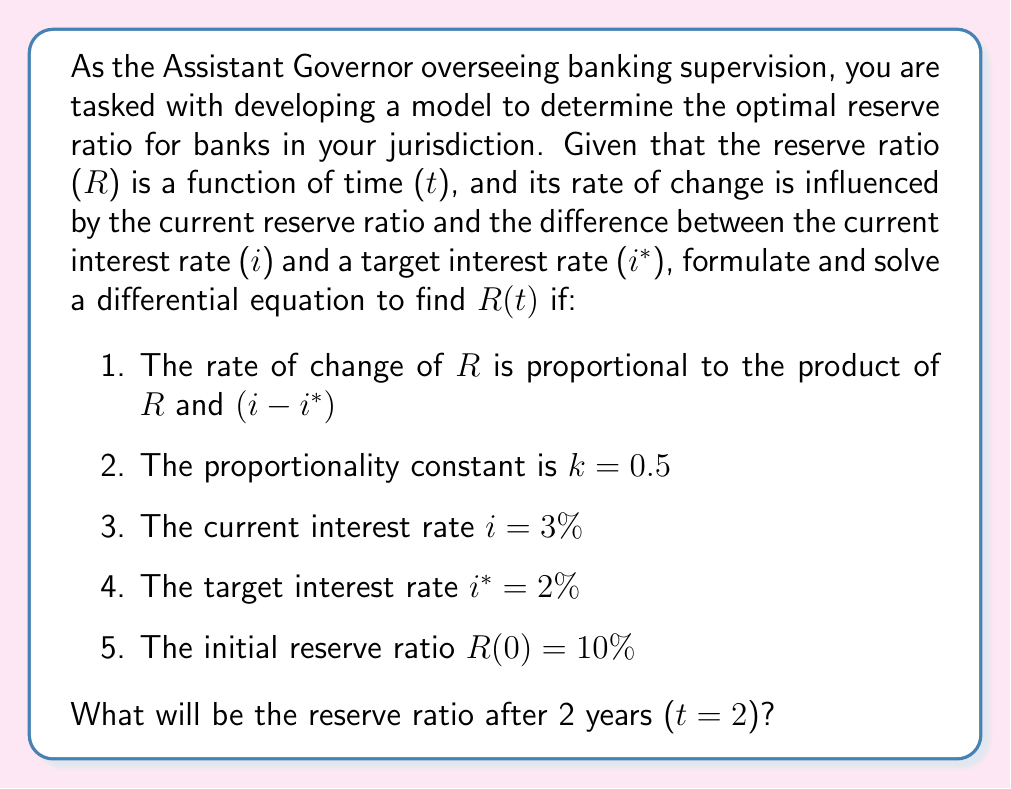Provide a solution to this math problem. To solve this problem, we need to follow these steps:

1. Formulate the differential equation:
   The rate of change of R with respect to t is given by:
   $$\frac{dR}{dt} = kR(i - i*)$$

2. Substitute the given values:
   $$\frac{dR}{dt} = 0.5R(0.03 - 0.02) = 0.005R$$

3. Solve the differential equation:
   This is a separable differential equation. We can rewrite it as:
   $$\frac{dR}{R} = 0.005dt$$

   Integrating both sides:
   $$\int \frac{dR}{R} = \int 0.005dt$$
   $$\ln|R| = 0.005t + C$$

   Taking the exponential of both sides:
   $$R = e^{0.005t + C} = e^C \cdot e^{0.005t}$$

4. Use the initial condition to find C:
   At t = 0, R = 0.10
   $$0.10 = e^C \cdot e^{0}$$
   $$e^C = 0.10$$
   $$C = \ln(0.10) = -2.30259$$

5. Write the general solution:
   $$R(t) = 0.10 \cdot e^{0.005t}$$

6. Calculate R(2):
   $$R(2) = 0.10 \cdot e^{0.005 \cdot 2} = 0.10 \cdot e^{0.01} = 0.10 \cdot 1.01005 = 0.1010050$$

Therefore, after 2 years, the reserve ratio will be approximately 10.10050%.
Answer: The reserve ratio after 2 years will be approximately 10.10050%. 